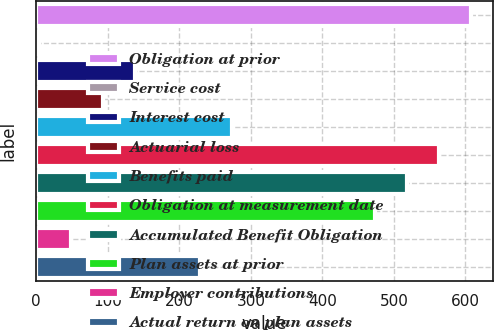<chart> <loc_0><loc_0><loc_500><loc_500><bar_chart><fcel>Obligation at prior<fcel>Service cost<fcel>Interest cost<fcel>Actuarial loss<fcel>Benefits paid<fcel>Obligation at measurement date<fcel>Accumulated Benefit Obligation<fcel>Plan assets at prior<fcel>Employer contributions<fcel>Actual return on plan assets<nl><fcel>607.6<fcel>4<fcel>138.7<fcel>93.8<fcel>273.4<fcel>562.7<fcel>517.8<fcel>472.9<fcel>48.9<fcel>228.5<nl></chart> 